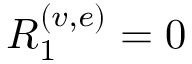Convert formula to latex. <formula><loc_0><loc_0><loc_500><loc_500>R _ { 1 } ^ { ( v , e ) } = 0</formula> 